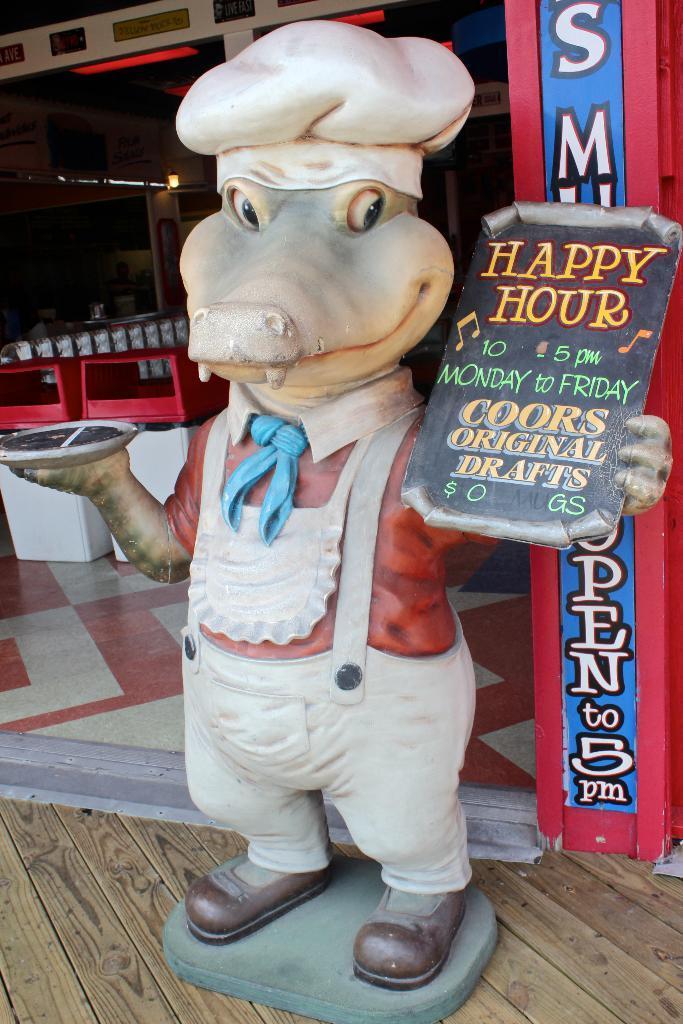Please provide a concise description of this image. In this picture I can see there is a toy of a crocodile and it is wearing a apron, hat, holding a board and a plate. In the backdrop there are few chairs and a banner and table. 